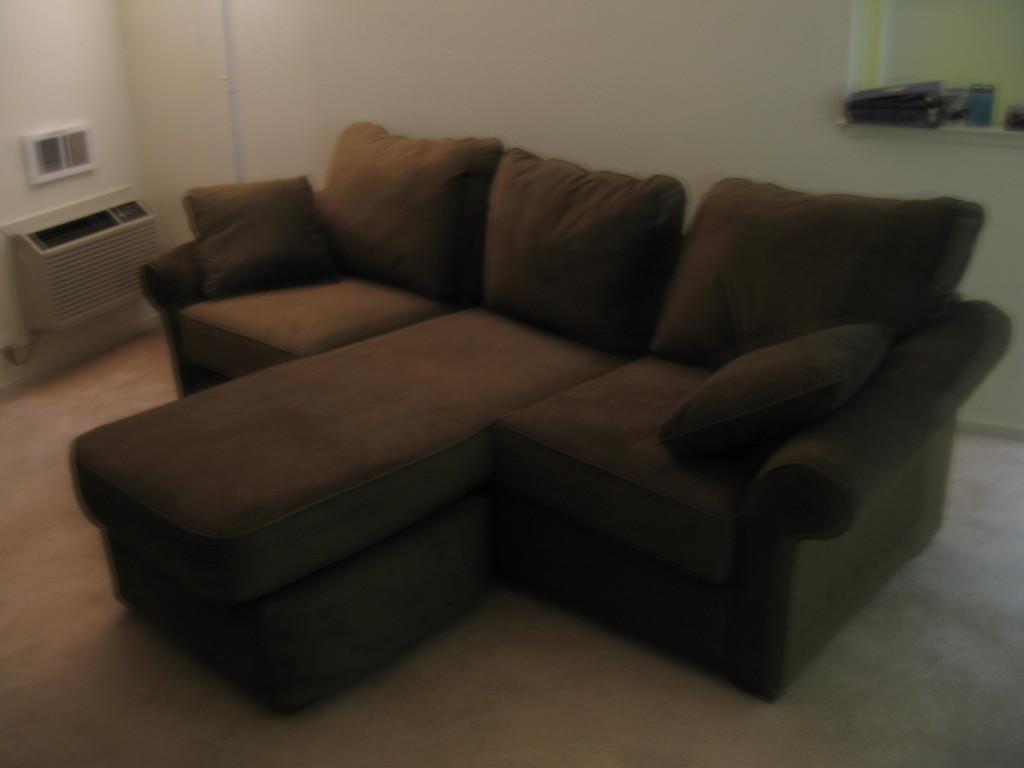Can you describe this image briefly? As we can see in the image there are brown colored sofas and white color wall. 